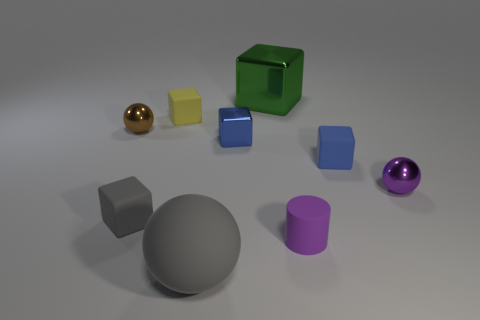There is a rubber object that is the same shape as the brown metal thing; what is its size?
Keep it short and to the point. Large. Are there fewer small purple shiny objects left of the tiny purple shiny thing than big blue metallic objects?
Provide a short and direct response. No. What size is the rubber sphere that is on the left side of the green metallic object?
Your response must be concise. Large. There is another large thing that is the same shape as the brown thing; what is its color?
Your answer should be compact. Gray. What number of small matte blocks have the same color as the big sphere?
Provide a short and direct response. 1. Is there anything else that is the same shape as the small purple matte object?
Keep it short and to the point. No. There is a blue object that is on the left side of the matte cube that is right of the large rubber object; are there any gray objects in front of it?
Your answer should be very brief. Yes. How many big blue objects have the same material as the purple sphere?
Your response must be concise. 0. Does the block that is right of the large green thing have the same size as the brown shiny thing to the left of the matte cylinder?
Your answer should be compact. Yes. There is a small block left of the rubber cube that is behind the tiny shiny thing to the left of the gray matte ball; what color is it?
Provide a succinct answer. Gray. 